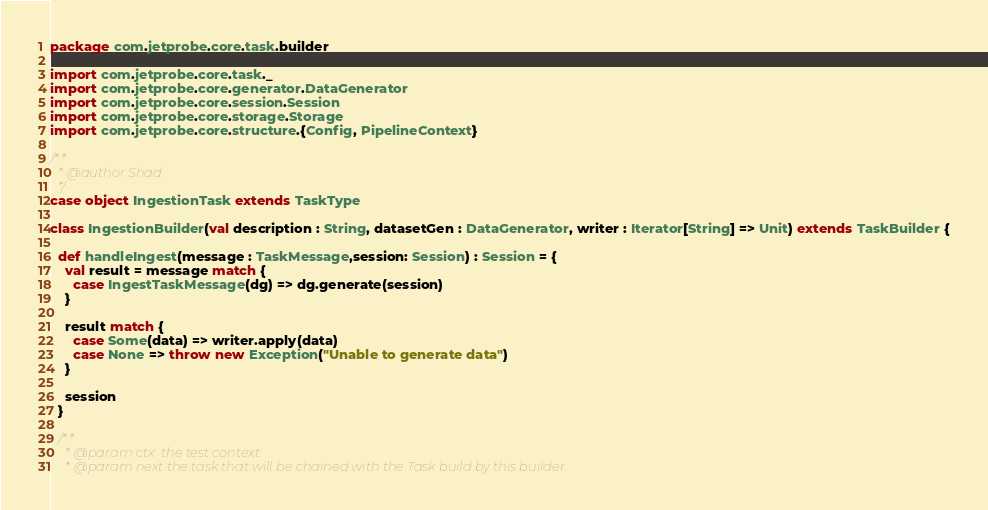<code> <loc_0><loc_0><loc_500><loc_500><_Scala_>package com.jetprobe.core.task.builder

import com.jetprobe.core.task._
import com.jetprobe.core.generator.DataGenerator
import com.jetprobe.core.session.Session
import com.jetprobe.core.storage.Storage
import com.jetprobe.core.structure.{Config, PipelineContext}

/**
  * @author Shad.
  */
case object IngestionTask extends TaskType

class IngestionBuilder(val description : String, datasetGen : DataGenerator, writer : Iterator[String] => Unit) extends TaskBuilder {

  def handleIngest(message : TaskMessage,session: Session) : Session = {
    val result = message match {
      case IngestTaskMessage(dg) => dg.generate(session)
    }

    result match {
      case Some(data) => writer.apply(data)
      case None => throw new Exception("Unable to generate data")
    }

    session
  }

  /**
    * @param ctx  the test context
    * @param next the task that will be chained with the Task build by this builder</code> 